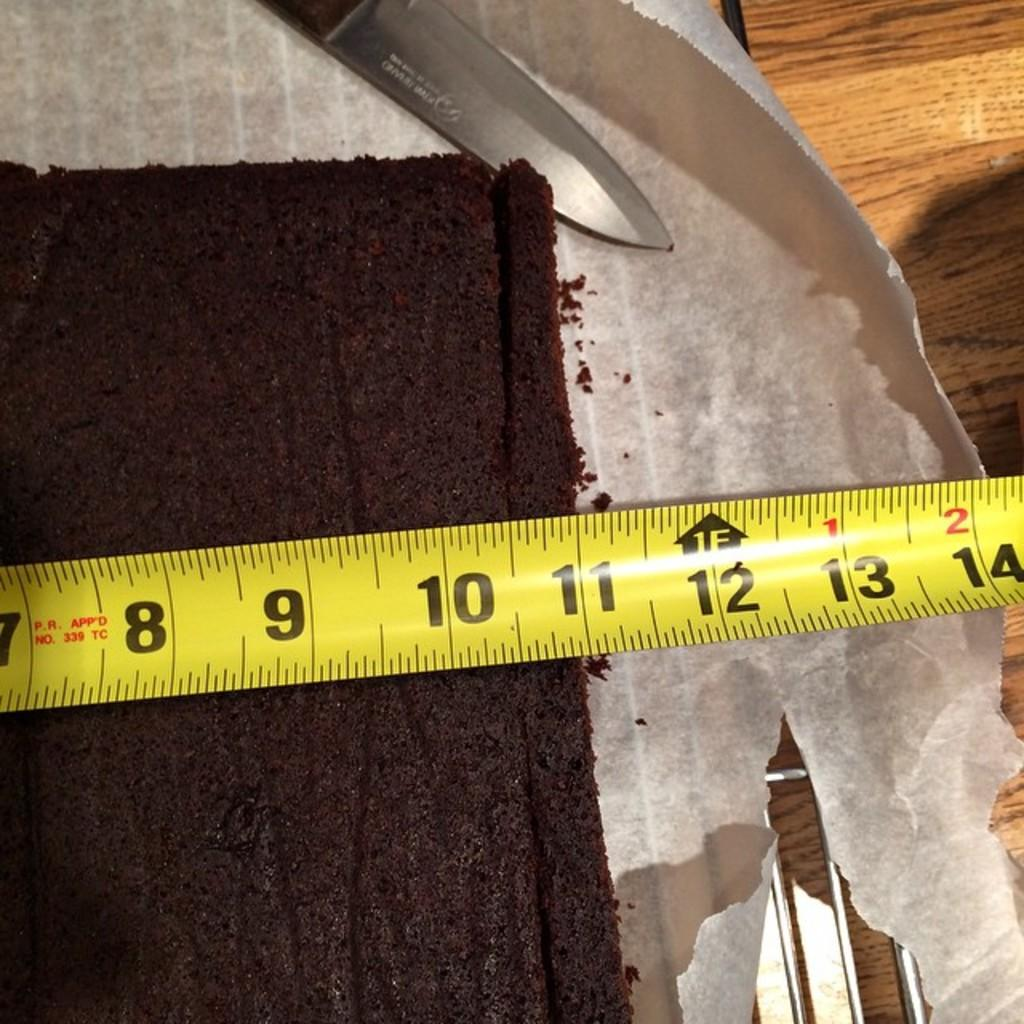<image>
Summarize the visual content of the image. A measuring tape that says "no. 339 TC" on it is being used to measure a chocolate cake. 